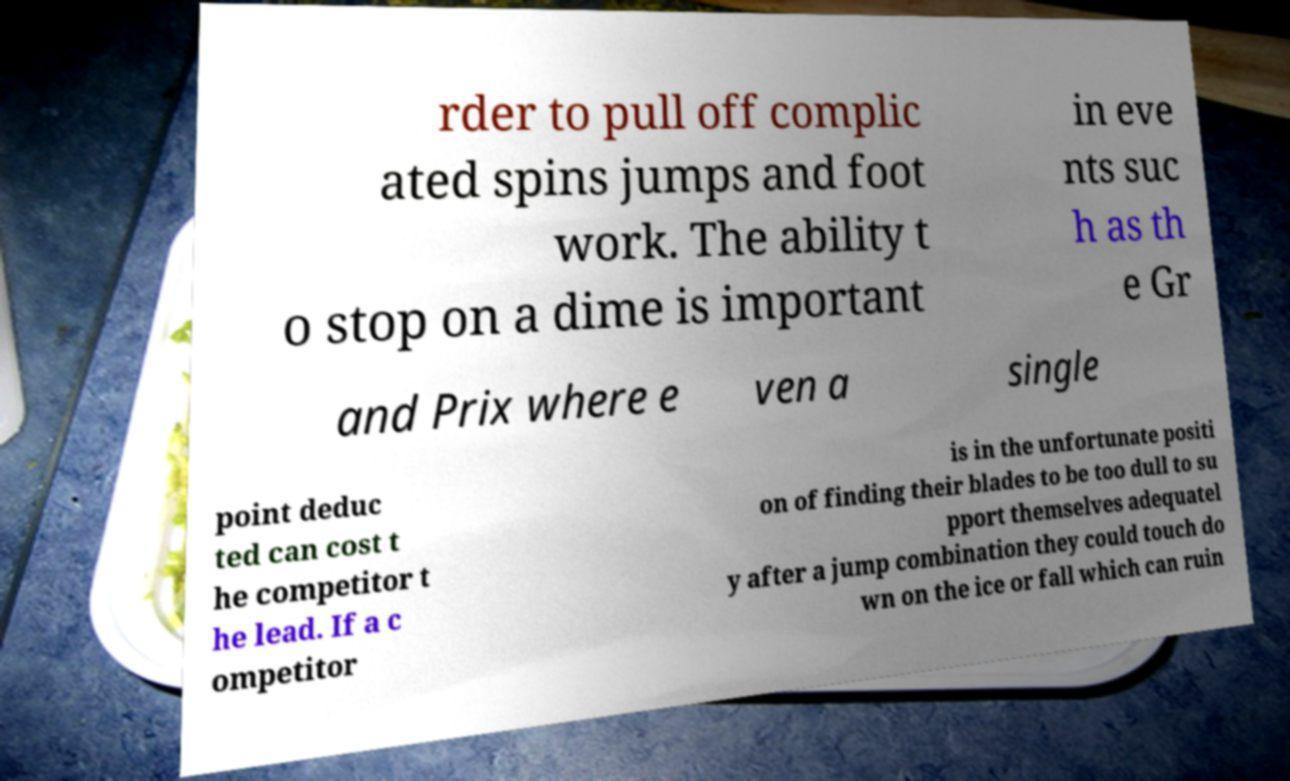Can you read and provide the text displayed in the image?This photo seems to have some interesting text. Can you extract and type it out for me? rder to pull off complic ated spins jumps and foot work. The ability t o stop on a dime is important in eve nts suc h as th e Gr and Prix where e ven a single point deduc ted can cost t he competitor t he lead. If a c ompetitor is in the unfortunate positi on of finding their blades to be too dull to su pport themselves adequatel y after a jump combination they could touch do wn on the ice or fall which can ruin 